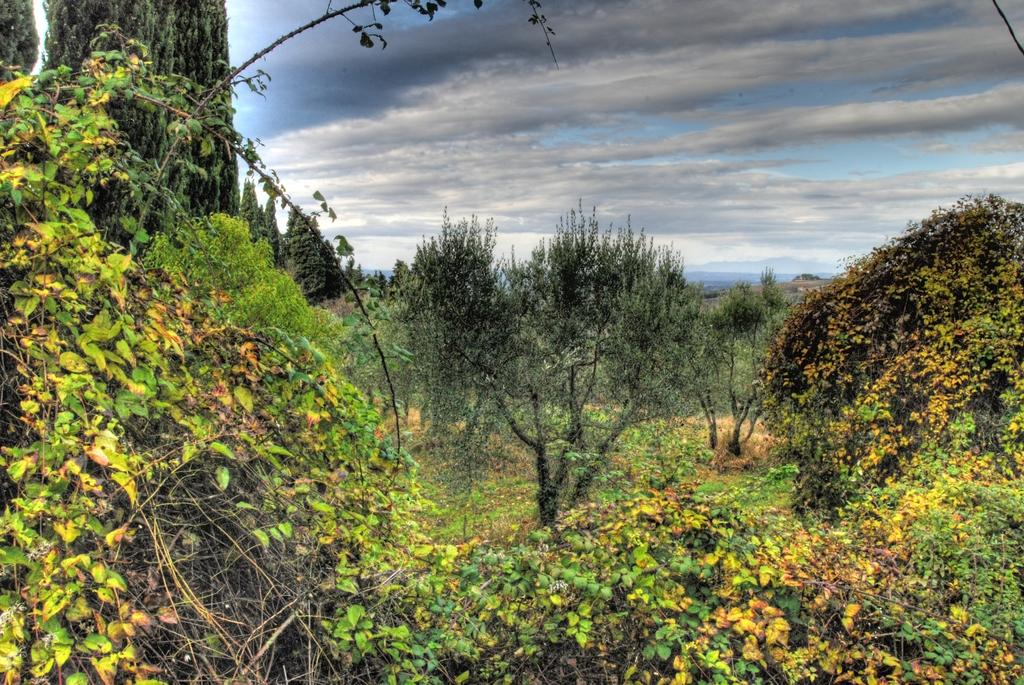What type of vegetation can be seen in the image? There are many trees in the image. Are there any other plants visible besides trees? Yes, there are creepers in the image. What can be seen in the background of the image? The sky is visible in the background of the image. What is the condition of the sky in the image? Clouds are present in the sky. What type of card is being used to treat the chin in the image? There is no card or treatment for a chin present in the image; it features trees, creepers, and a sky with clouds. 